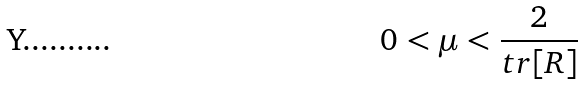<formula> <loc_0><loc_0><loc_500><loc_500>0 < \mu < \frac { 2 } { t r [ R ] }</formula> 